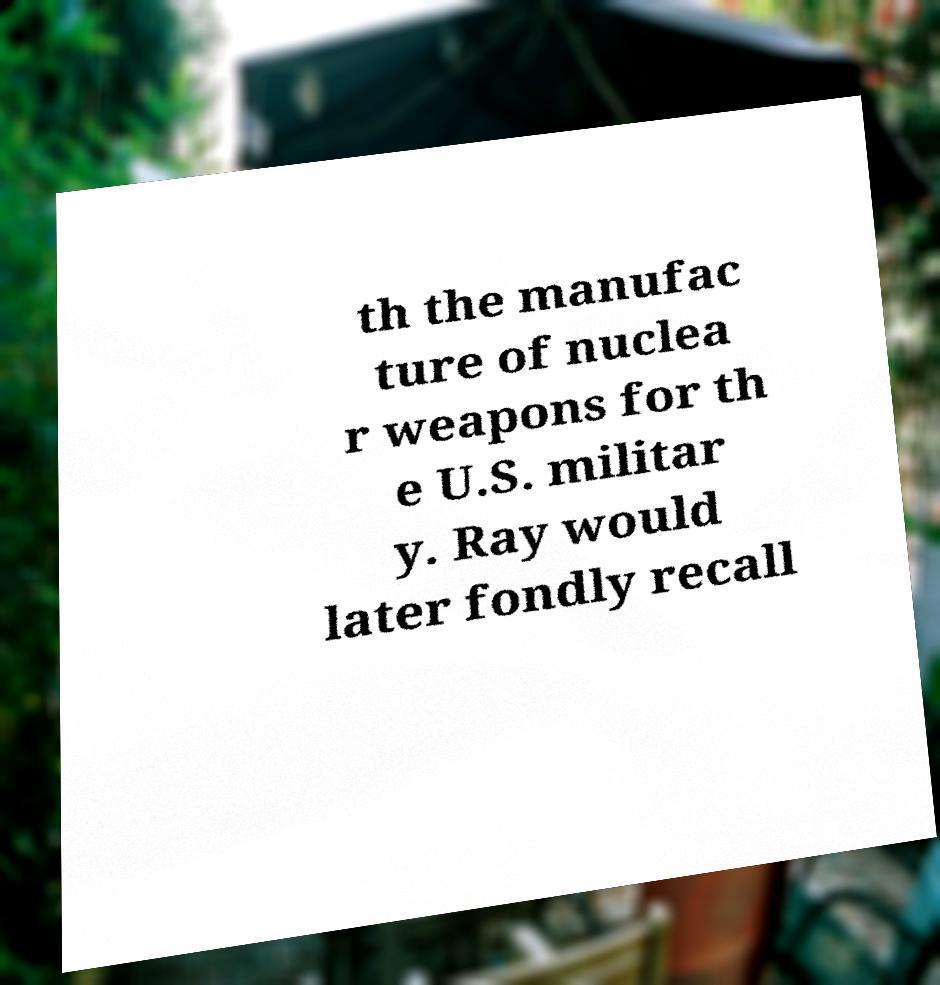Can you read and provide the text displayed in the image?This photo seems to have some interesting text. Can you extract and type it out for me? th the manufac ture of nuclea r weapons for th e U.S. militar y. Ray would later fondly recall 